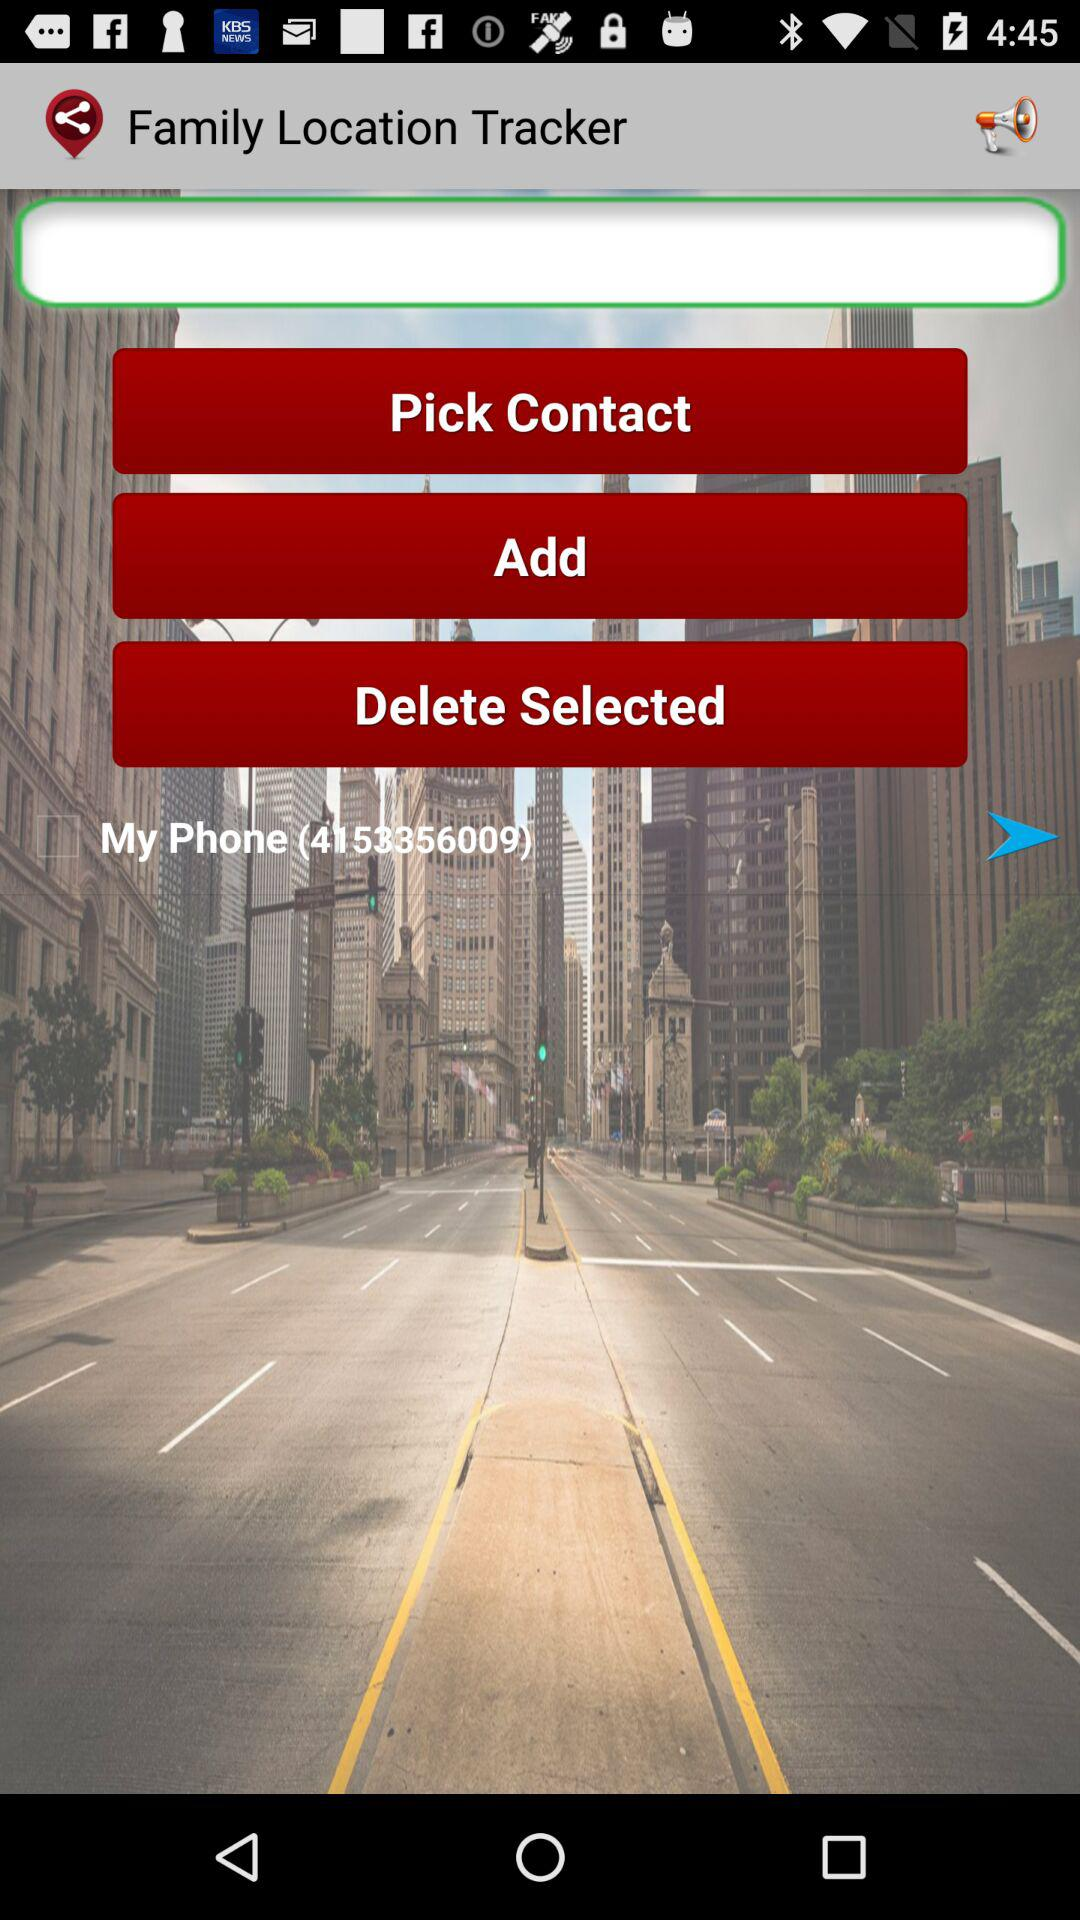What is the application name? The application name is "Family Location Tracker". 